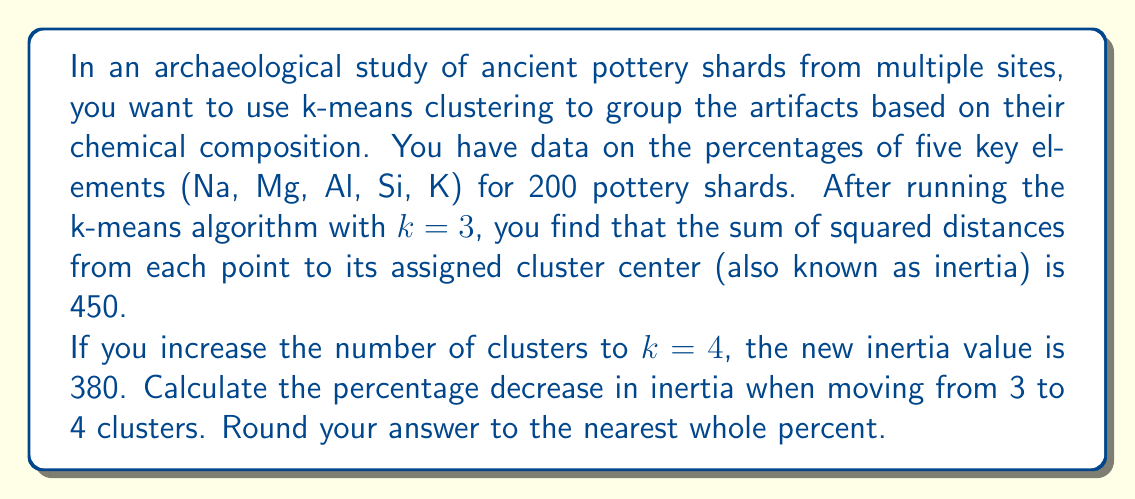Teach me how to tackle this problem. To solve this problem, we need to follow these steps:

1. Identify the inertia values:
   - For $k=3$, inertia = 450
   - For $k=4$, inertia = 380

2. Calculate the decrease in inertia:
   $$\text{Decrease} = \text{Inertia}_{k=3} - \text{Inertia}_{k=4} = 450 - 380 = 70$$

3. Calculate the percentage decrease:
   $$\text{Percentage decrease} = \frac{\text{Decrease}}{\text{Original Value}} \times 100\%$$
   $$= \frac{70}{450} \times 100\%$$
   $$= 0.1555... \times 100\%$$
   $$= 15.55...\%$$

4. Round to the nearest whole percent:
   15.55% rounds to 16%

This percentage decrease in inertia indicates the improvement in the clustering solution when increasing from 3 to 4 clusters. A larger decrease suggests that the new clustering solution fits the data better, which could indicate that 4 clusters might be more appropriate for this dataset than 3 clusters.
Answer: 16% 